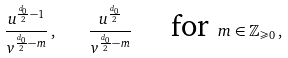Convert formula to latex. <formula><loc_0><loc_0><loc_500><loc_500>\frac { u ^ { \frac { d _ { 0 } } { 2 } - 1 } } { v ^ { \frac { d _ { 0 } } { 2 } - m } } \, , \quad \frac { u ^ { \frac { d _ { 0 } } { 2 } } } { v ^ { \frac { d _ { 0 } } { 2 } - m } } \quad \text { for } m \in \mathbb { Z } _ { \geqslant 0 } \, ,</formula> 